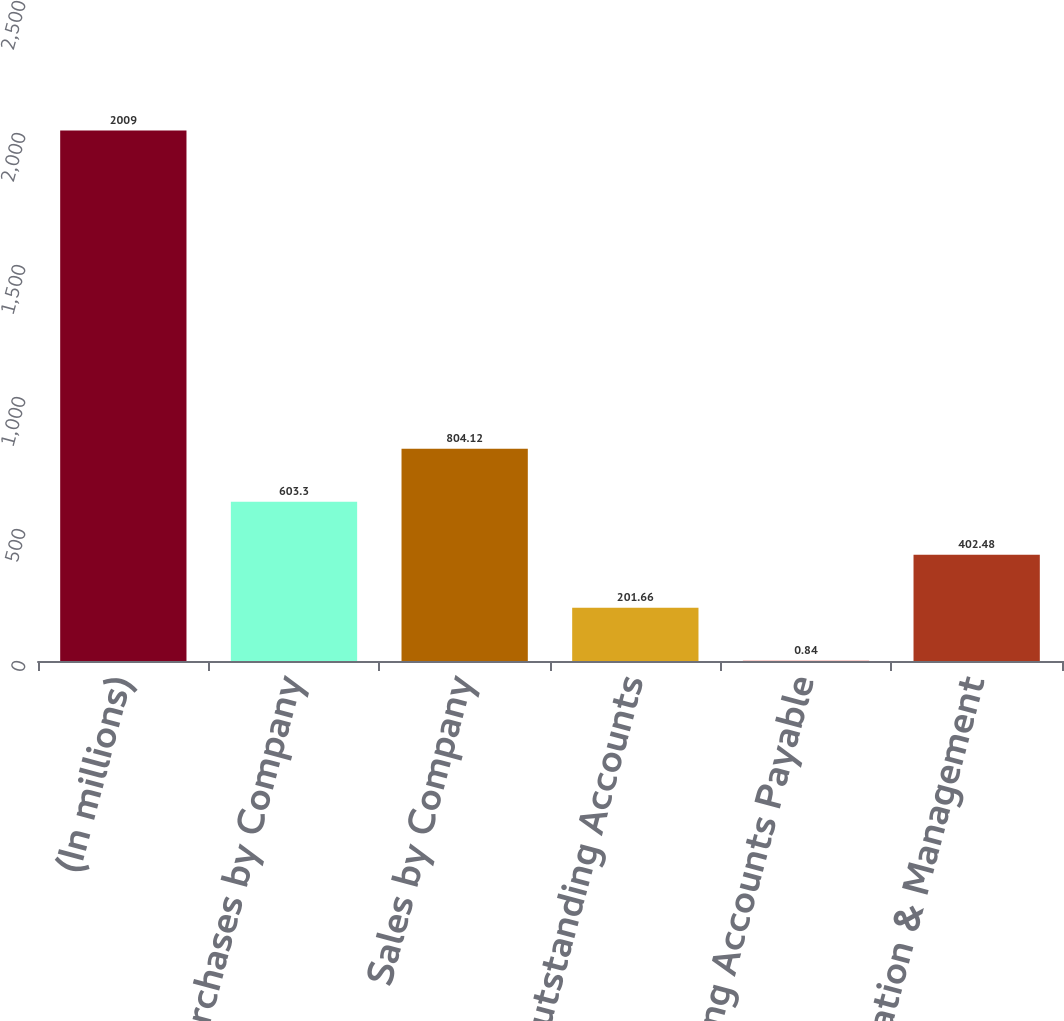<chart> <loc_0><loc_0><loc_500><loc_500><bar_chart><fcel>(In millions)<fcel>Purchases by Company<fcel>Sales by Company<fcel>Outstanding Accounts<fcel>Outstanding Accounts Payable<fcel>Administration & Management<nl><fcel>2009<fcel>603.3<fcel>804.12<fcel>201.66<fcel>0.84<fcel>402.48<nl></chart> 